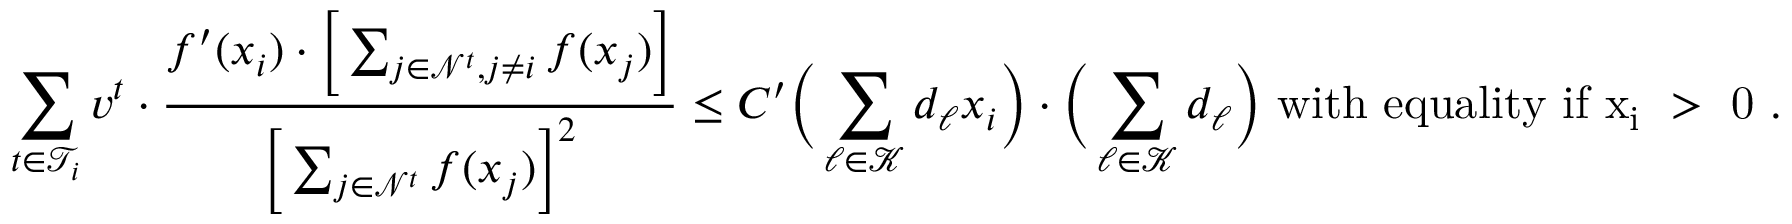Convert formula to latex. <formula><loc_0><loc_0><loc_500><loc_500>\sum _ { t \in \mathcal { T } _ { i } } v ^ { t } \cdot \frac { f ^ { \prime } ( x _ { i } ) \cdot \left [ \sum _ { j \in \mathcal { N } ^ { t } , j \ne i } f ( x _ { j } ) \right ] } { \left [ \sum _ { j \in \mathcal { N } ^ { t } } f ( x _ { j } ) \right ] ^ { 2 } } \leq C ^ { \prime } \left ( \sum _ { \ell \in \mathcal { K } } d _ { \ell } x _ { i } \right ) \cdot \left ( \sum _ { \ell \in \mathcal { K } } d _ { \ell } \right ) w i t h e q u a l i t y i f x _ { i } > 0 .</formula> 